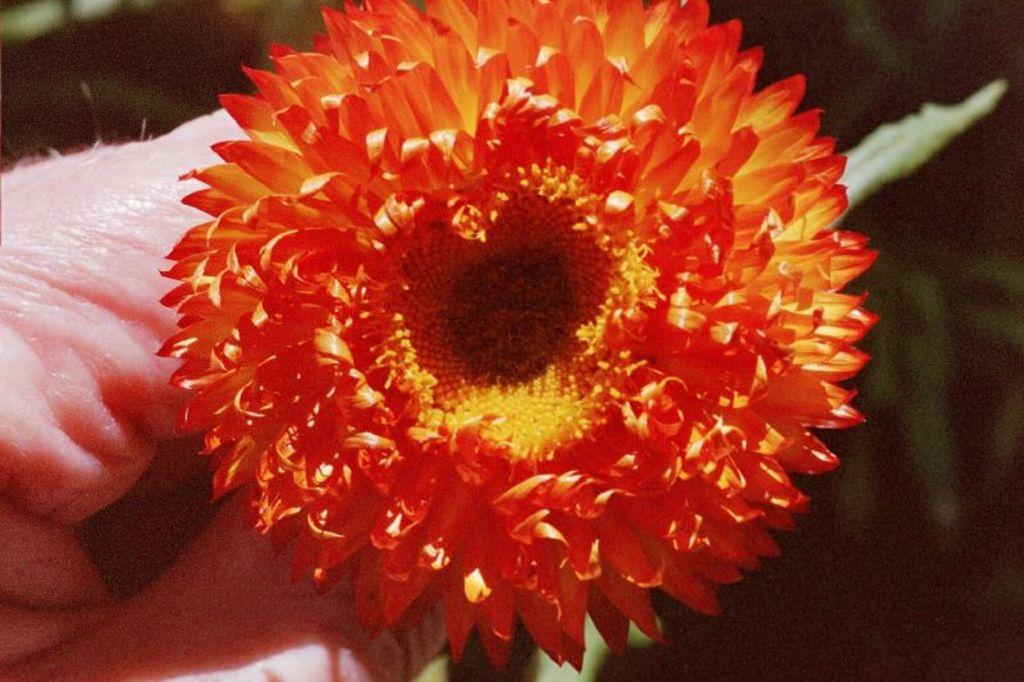What object is being held by the person in the image? There is a flower in the hand of a person in the image. Can you describe the background of the image? The background of the image is blurry. Where is the squirrel hiding in the image? There is no squirrel present in the image. What level of difficulty is the person experiencing while holding the flower in the image? The image does not provide information about the level of difficulty the person is experiencing. 